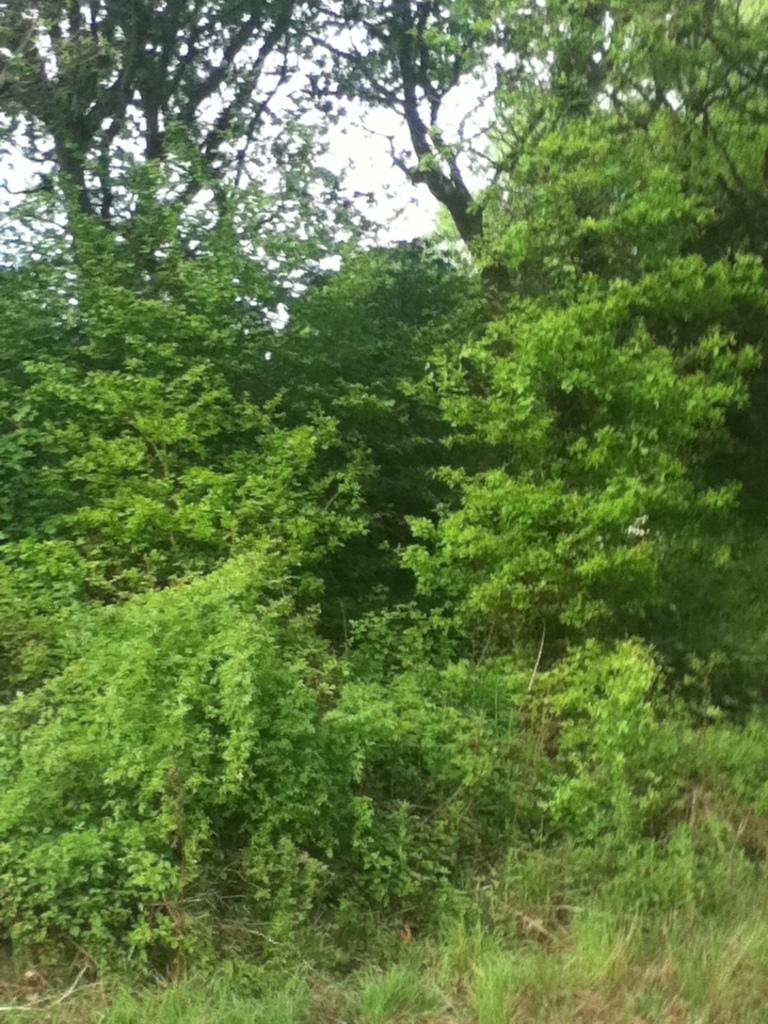What type of vegetation can be seen in the image? There are many trees and plants in the image. What part of the natural environment is visible in the image? The sky is visible in the image. What type of twig is being used as a vessel in the image? There is no twig or vessel present in the image. How many hands can be seen holding the plants in the image? There are no hands visible in the image; it only features trees, plants, and the sky. 